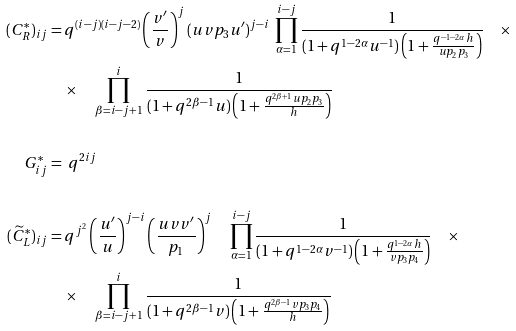<formula> <loc_0><loc_0><loc_500><loc_500>( C ^ { * } _ { R } ) _ { i j } & = q ^ { ( i - j ) ( i - j - 2 ) } \left ( \frac { v ^ { \prime } } { v } \right ) ^ { j } ( u v p _ { 3 } u ^ { \prime } ) ^ { j - i } \ \prod _ { \alpha = 1 } ^ { i - j } \frac { 1 } { ( 1 + q ^ { 1 - 2 \alpha } u ^ { - 1 } ) \left ( 1 + \frac { q ^ { - 1 - 2 \alpha } h } { u p _ { 2 } p _ { 3 } } \right ) } \quad \times \\ & \quad \times \quad \prod _ { \beta = i - j + 1 } ^ { i } \frac { 1 } { ( 1 + q ^ { 2 \beta - 1 } u ) \left ( 1 + \frac { q ^ { 2 \beta + 1 } u p _ { 2 } p _ { 3 } } { h } \right ) } \\ \\ G ^ { * } _ { i j } & = \ q ^ { 2 i j } \\ \\ ( \widetilde { C } ^ { * } _ { L } ) _ { i j } & = q ^ { j ^ { 2 } } \left ( \frac { u ^ { \prime } } { u } \right ) ^ { j - i } \left ( \frac { u v v ^ { \prime } } { p _ { 1 } } \right ) ^ { j } \quad \prod _ { \alpha = 1 } ^ { i - j } \frac { 1 } { ( 1 + q ^ { 1 - 2 \alpha } v ^ { - 1 } ) \left ( 1 + \frac { q ^ { 1 - 2 \alpha } h } { v p _ { 3 } p _ { 4 } } \right ) } \quad \times \\ & \quad \times \quad \prod _ { \beta = i - j + 1 } ^ { i } \frac { 1 } { ( 1 + q ^ { 2 \beta - 1 } v ) \left ( 1 + \frac { q ^ { 2 \beta - 1 } v p _ { 3 } p _ { 4 } } { h } \right ) }</formula> 